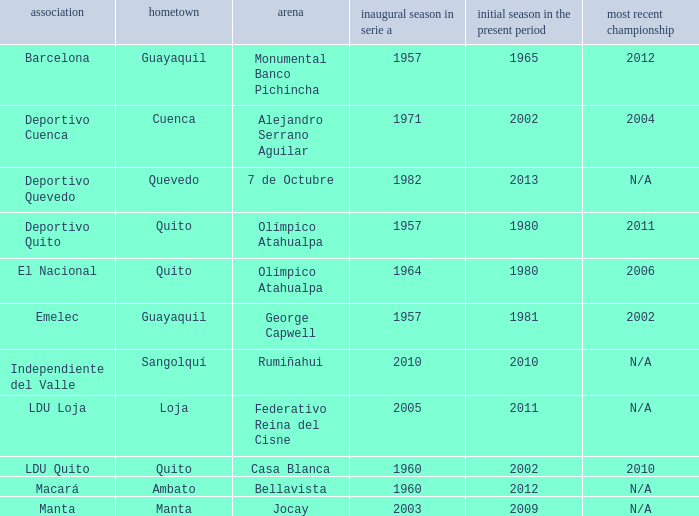Name the club for quevedo Deportivo Quevedo. 